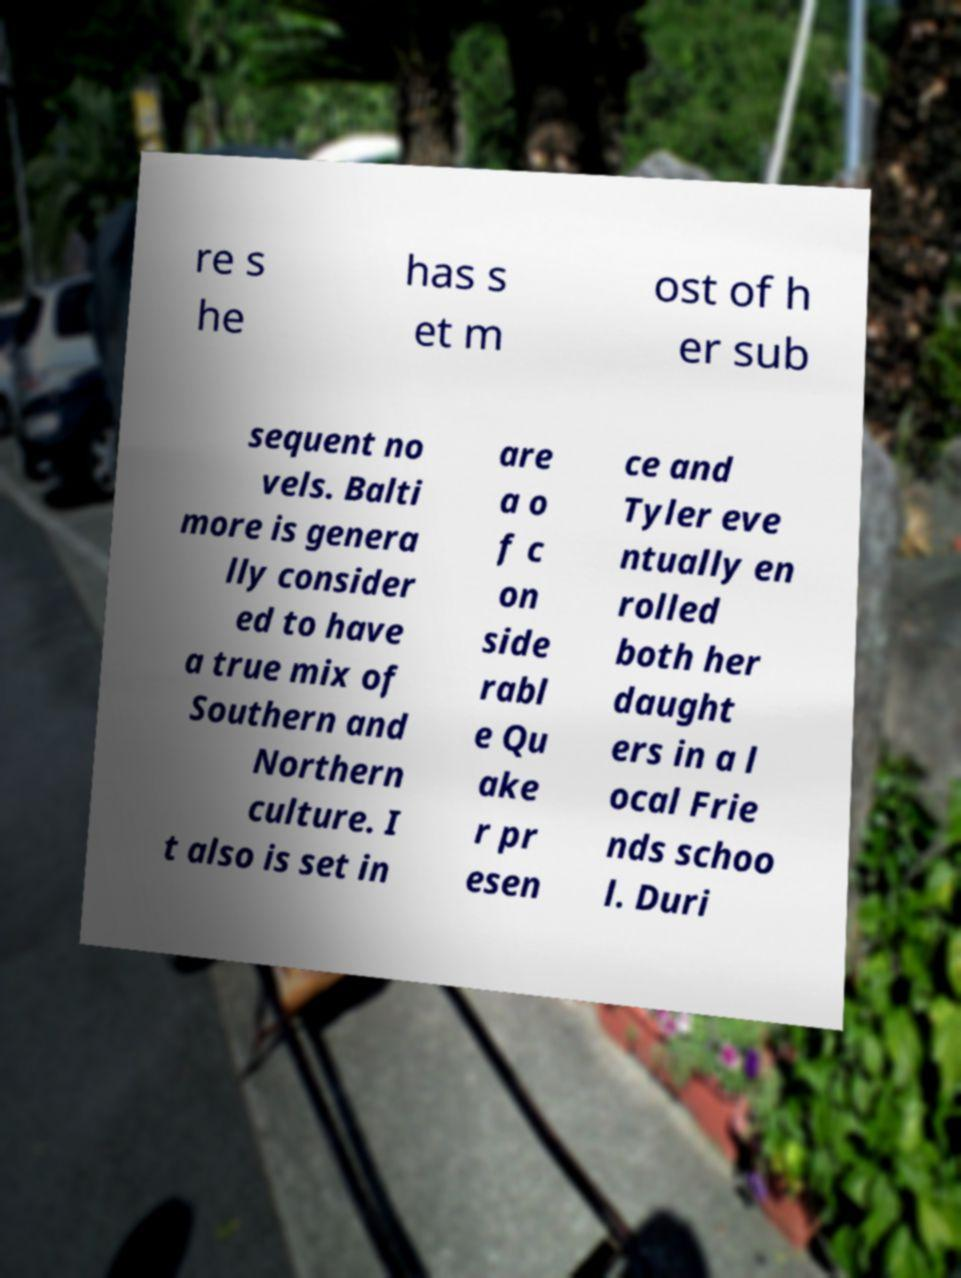Can you accurately transcribe the text from the provided image for me? re s he has s et m ost of h er sub sequent no vels. Balti more is genera lly consider ed to have a true mix of Southern and Northern culture. I t also is set in are a o f c on side rabl e Qu ake r pr esen ce and Tyler eve ntually en rolled both her daught ers in a l ocal Frie nds schoo l. Duri 